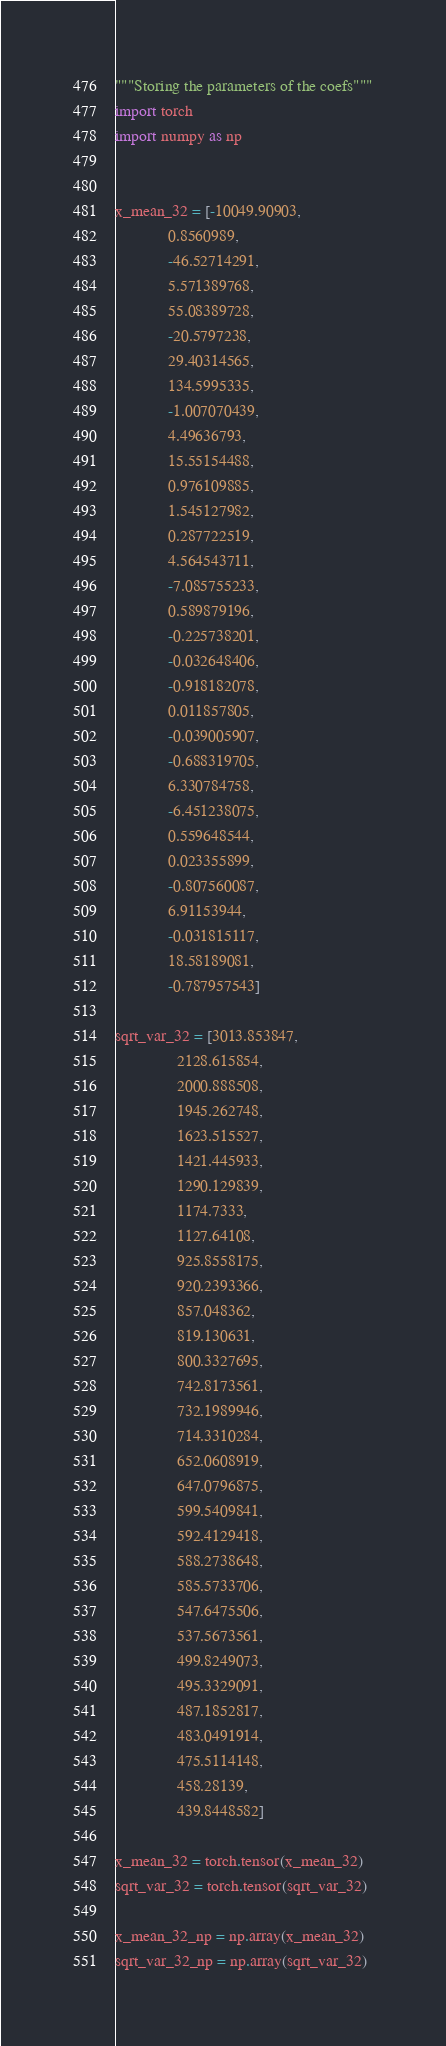<code> <loc_0><loc_0><loc_500><loc_500><_Python_>"""Storing the parameters of the coefs"""
import torch
import numpy as np


x_mean_32 = [-10049.90903,
             0.8560989,
             -46.52714291,
             5.571389768,
             55.08389728,
             -20.5797238,
             29.40314565,
             134.5995335,
             -1.007070439,
             4.49636793,
             15.55154488,
             0.976109885,
             1.545127982,
             0.287722519,
             4.564543711,
             -7.085755233,
             0.589879196,
             -0.225738201,
             -0.032648406,
             -0.918182078,
             0.011857805,
             -0.039005907,
             -0.688319705,
             6.330784758,
             -6.451238075,
             0.559648544,
             0.023355899,
             -0.807560087,
             6.91153944,
             -0.031815117,
             18.58189081,
             -0.787957543]

sqrt_var_32 = [3013.853847,
               2128.615854,
               2000.888508,
               1945.262748,
               1623.515527,
               1421.445933,
               1290.129839,
               1174.7333,
               1127.64108,
               925.8558175,
               920.2393366,
               857.048362,
               819.130631,
               800.3327695,
               742.8173561,
               732.1989946,
               714.3310284,
               652.0608919,
               647.0796875,
               599.5409841,
               592.4129418,
               588.2738648,
               585.5733706,
               547.6475506,
               537.5673561,
               499.8249073,
               495.3329091,
               487.1852817,
               483.0491914,
               475.5114148,
               458.28139,
               439.8448582]

x_mean_32 = torch.tensor(x_mean_32)
sqrt_var_32 = torch.tensor(sqrt_var_32)

x_mean_32_np = np.array(x_mean_32)
sqrt_var_32_np = np.array(sqrt_var_32)
</code> 